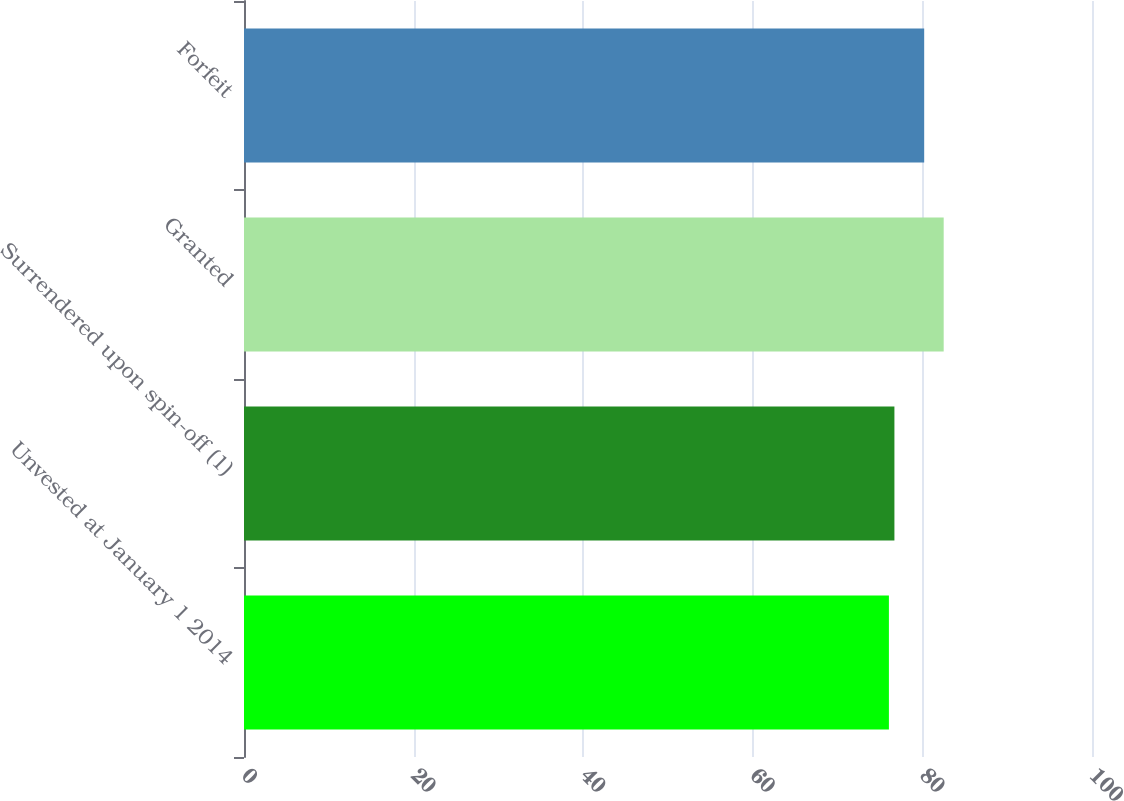Convert chart. <chart><loc_0><loc_0><loc_500><loc_500><bar_chart><fcel>Unvested at January 1 2014<fcel>Surrendered upon spin-off (1)<fcel>Granted<fcel>Forfeit<nl><fcel>76.05<fcel>76.7<fcel>82.51<fcel>80.21<nl></chart> 